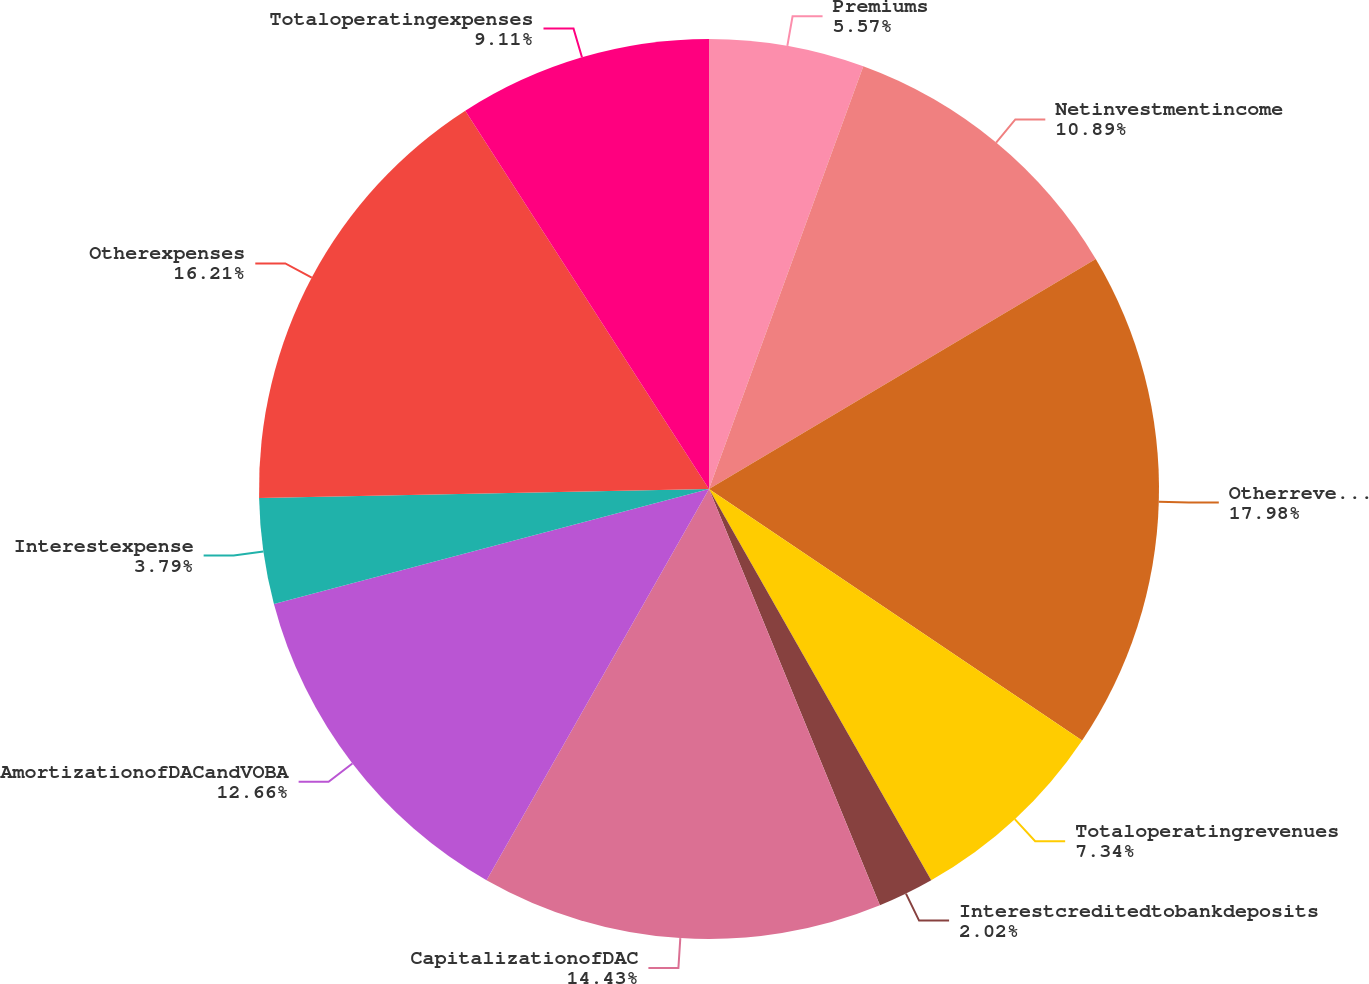Convert chart to OTSL. <chart><loc_0><loc_0><loc_500><loc_500><pie_chart><fcel>Premiums<fcel>Netinvestmentincome<fcel>Otherrevenues<fcel>Totaloperatingrevenues<fcel>Interestcreditedtobankdeposits<fcel>CapitalizationofDAC<fcel>AmortizationofDACandVOBA<fcel>Interestexpense<fcel>Otherexpenses<fcel>Totaloperatingexpenses<nl><fcel>5.57%<fcel>10.89%<fcel>17.98%<fcel>7.34%<fcel>2.02%<fcel>14.43%<fcel>12.66%<fcel>3.79%<fcel>16.21%<fcel>9.11%<nl></chart> 